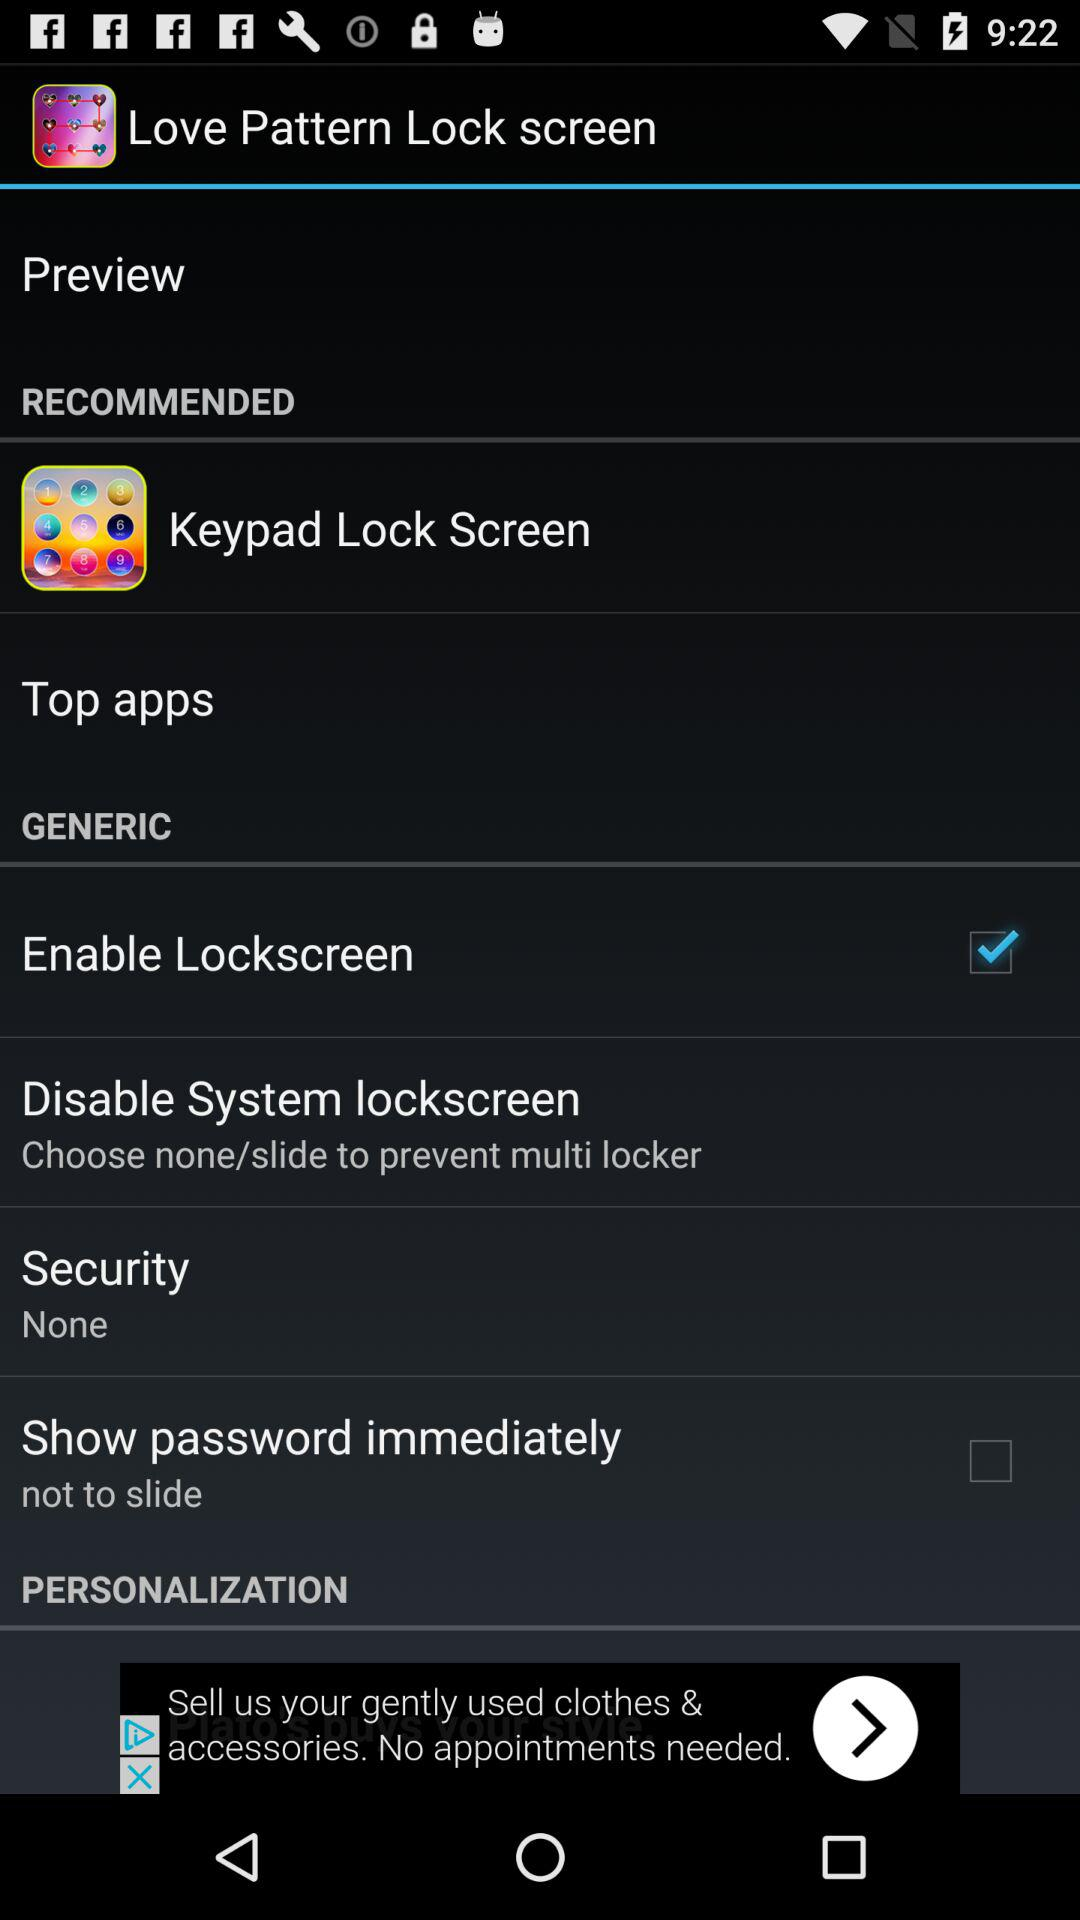What is the app name? The app name is "Love Pattern Lock screen". 